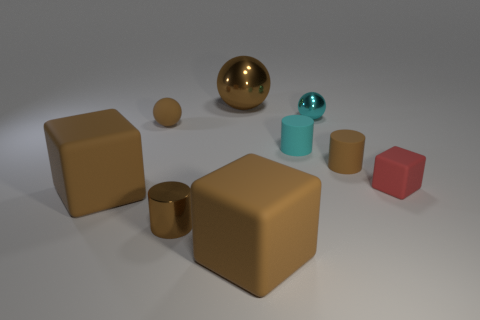The small metallic thing that is the same color as the tiny matte ball is what shape?
Your response must be concise. Cylinder. Is the color of the large metal sphere the same as the small metal cylinder?
Give a very brief answer. Yes. There is another metal object that is the same shape as the small cyan metal thing; what size is it?
Your answer should be compact. Large. The other tiny rubber thing that is the same shape as the cyan rubber thing is what color?
Keep it short and to the point. Brown. How many small matte objects have the same color as the tiny metal ball?
Offer a very short reply. 1. How many things are cyan spheres left of the small brown rubber cylinder or small blue cubes?
Make the answer very short. 1. Are there more tiny brown things that are to the left of the cyan metallic object than small brown things that are behind the cyan cylinder?
Provide a succinct answer. Yes. How many rubber objects are blocks or brown blocks?
Keep it short and to the point. 3. There is a large sphere that is the same color as the tiny metallic cylinder; what is it made of?
Keep it short and to the point. Metal. Are there fewer cubes that are behind the red matte object than large brown things behind the cyan metallic object?
Your answer should be very brief. Yes. 